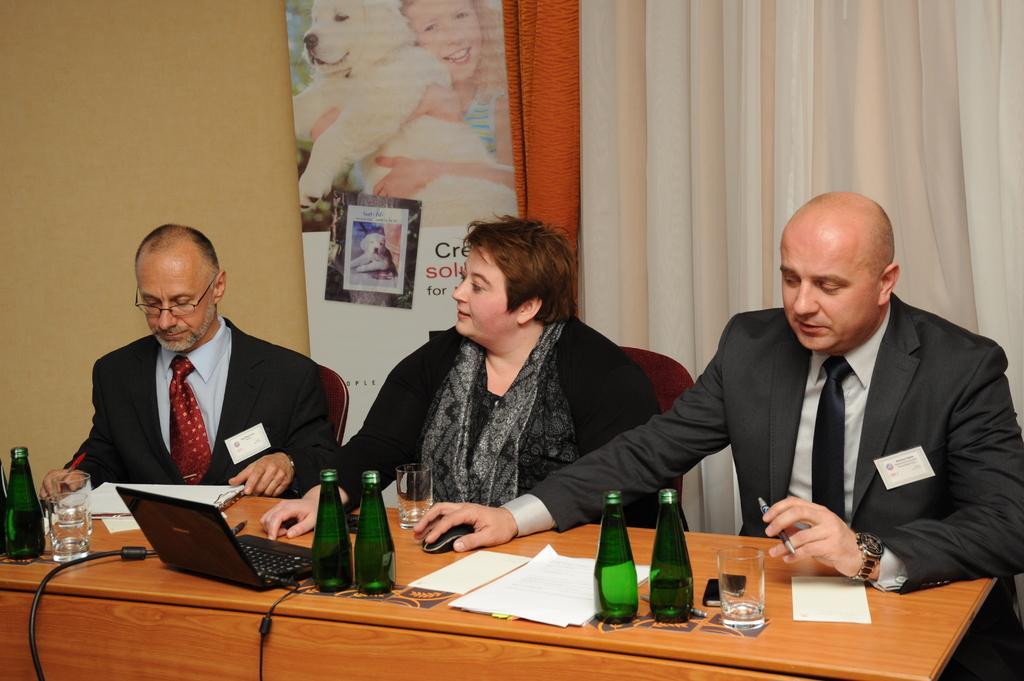Can you describe this image briefly? It looks like the image is clicked in a meeting room. There are three persons in this image. In the background there is a curtain, poster and wall. In the front there is a table, on which bottles, glass and laptop are kept. To the right, the man is wearing black suit, white shirt and black tie. To the left, the man is wearing black suit, red tie and white shirt. In the middle the woman is wearing black dress. 